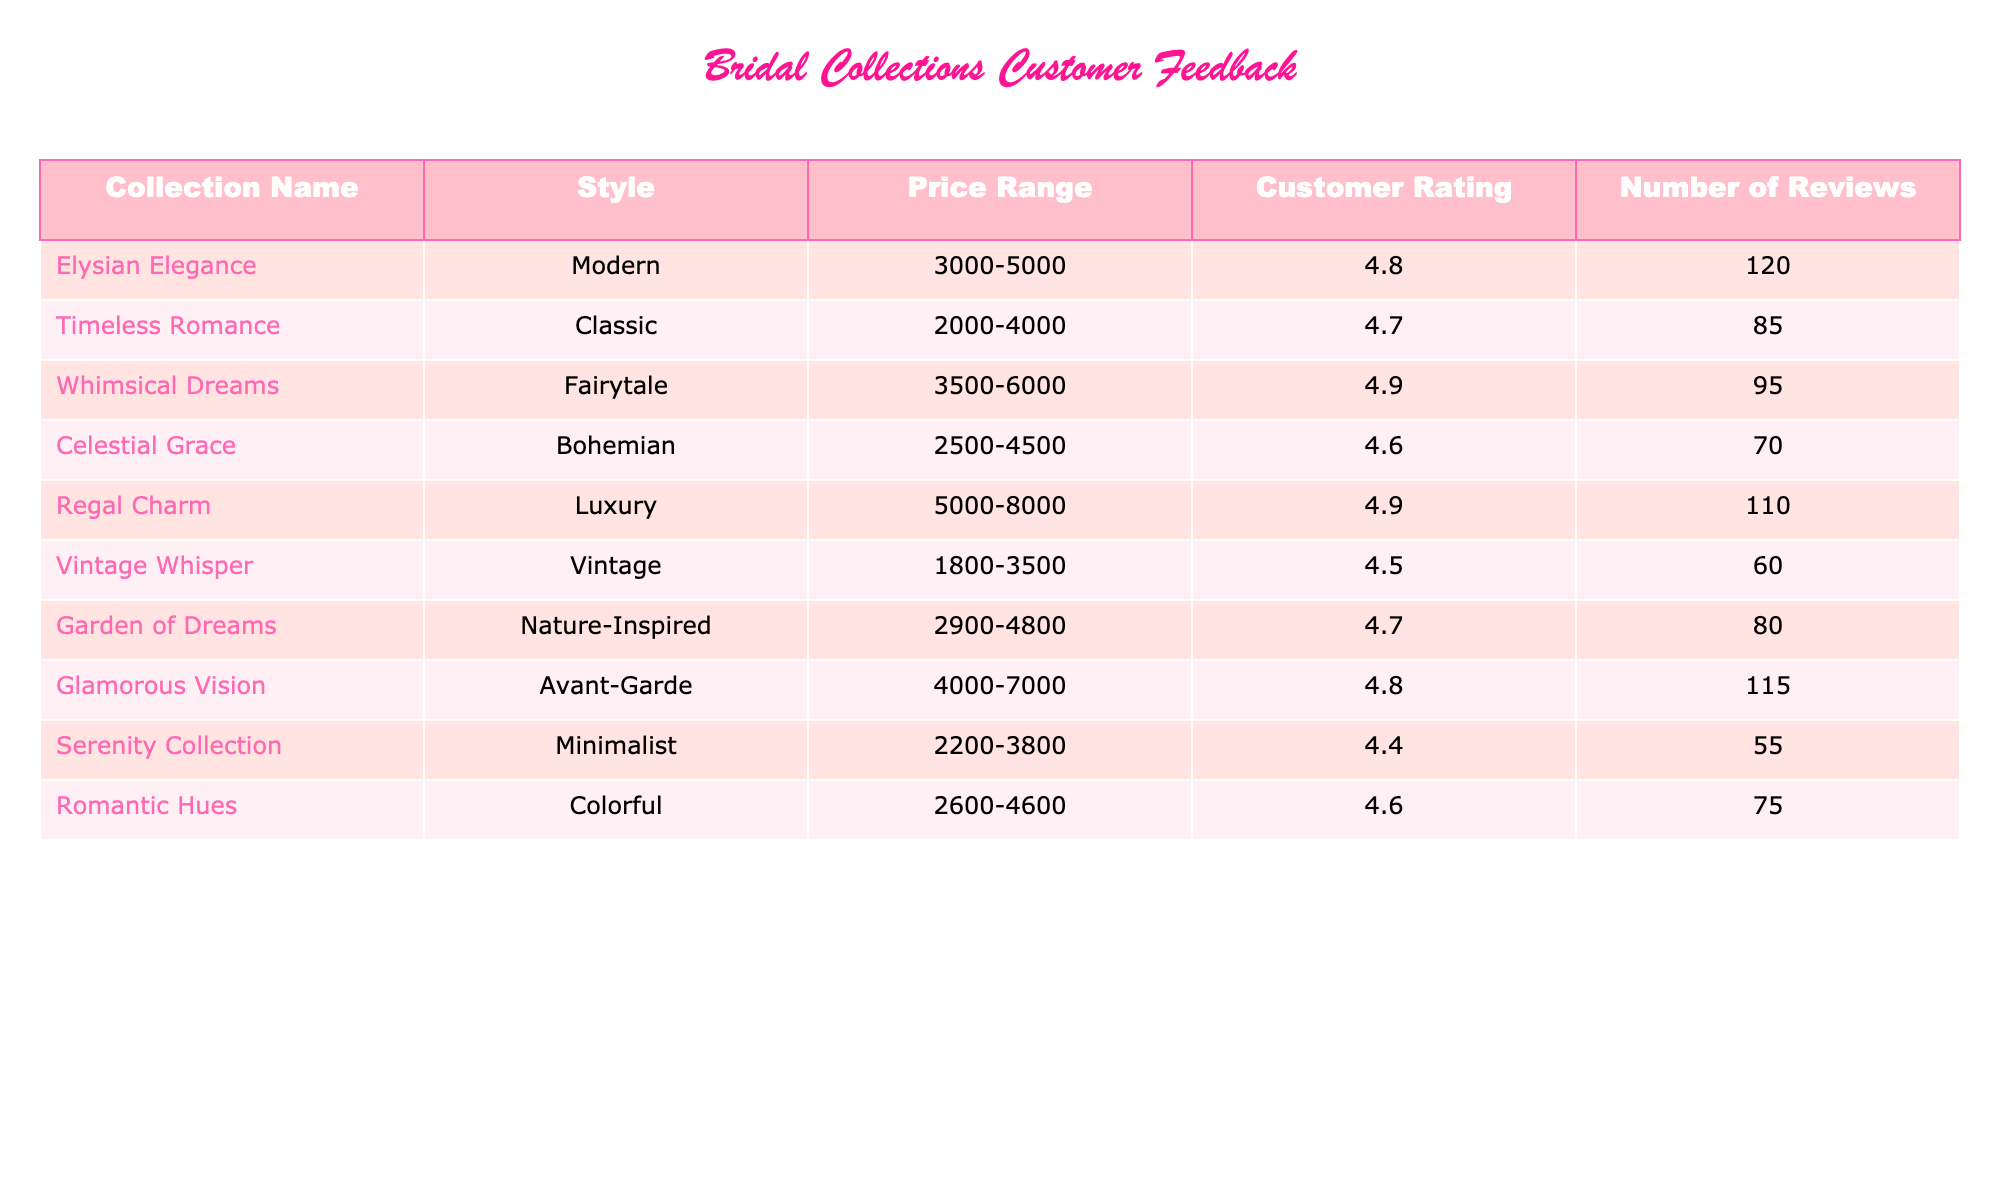What is the customer rating for the "Whimsical Dreams" collection? According to the table, the "Whimsical Dreams" collection has a customer rating of 4.9.
Answer: 4.9 Which collection has the highest number of reviews? By examining the table, the "Elysian Elegance" collection has the highest number of reviews at 120.
Answer: 120 What is the average customer rating for the collections with a price range above 4000? First, we identify collections priced above 4000: "Whimsical Dreams" (4.9), "Glamorous Vision" (4.8), and "Regal Charm" (4.9). Then, we compute the average: (4.9 + 4.8 + 4.9) / 3 = 4.867.
Answer: 4.867 Is there any collection categorized as "Vintage" that has a customer rating above 4.5? The "Vintage Whisper" collection is categorized as "Vintage" and has a customer rating of 4.5, which does not exceed 4.5. Therefore, the answer is no.
Answer: No What is the difference in customer ratings between the "Celestial Grace" and "Serenity Collection"? The customer rating for "Celestial Grace" is 4.6, and for "Serenity Collection" is 4.4. The difference is 4.6 - 4.4 = 0.2.
Answer: 0.2 How many collections have customer ratings higher than 4.6? By reviewing the table, the collections with ratings higher than 4.6 are: "Whimsical Dreams" (4.9), "Regal Charm" (4.9), "Glamorous Vision" (4.8), "Elysian Elegance" (4.8), and "Timeless Romance" (4.7). There are 5 such collections.
Answer: 5 Does the "Timeless Romance" collection have the same price range as the "Vintage Whisper" collection? The "Timeless Romance" collection has a price range of 2000-4000, while the "Vintage Whisper" collection has a price range of 1800-3500. Since these ranges do not match, the answer is no.
Answer: No What is the minimum customer rating among the collections priced between 2000 and 4000? The relevant collections in this price range are "Timeless Romance" (4.7), "Celestial Grace" (4.6), and "Serenity Collection" (4.4). The minimum rating among these is 4.4 from the "Serenity Collection."
Answer: 4.4 How does the average price range of the collections compare to the total number of reviews received? To compare, we need to determine the average price range. The total price range from each collection varies, and finding the average involves further calculation (this question would imply deeper calculations, possibly considering midpoints for ranges). However, for total reviews, we can sum the reviews (120 + 85 + 95 + 70 + 110 + 60 + 80 + 115 + 55 + 75 = 1,000). A complete answer would require verifying if the calculation aligns with the customer feedback received.
Answer: Average needs calculation. Total reviews: 1000 